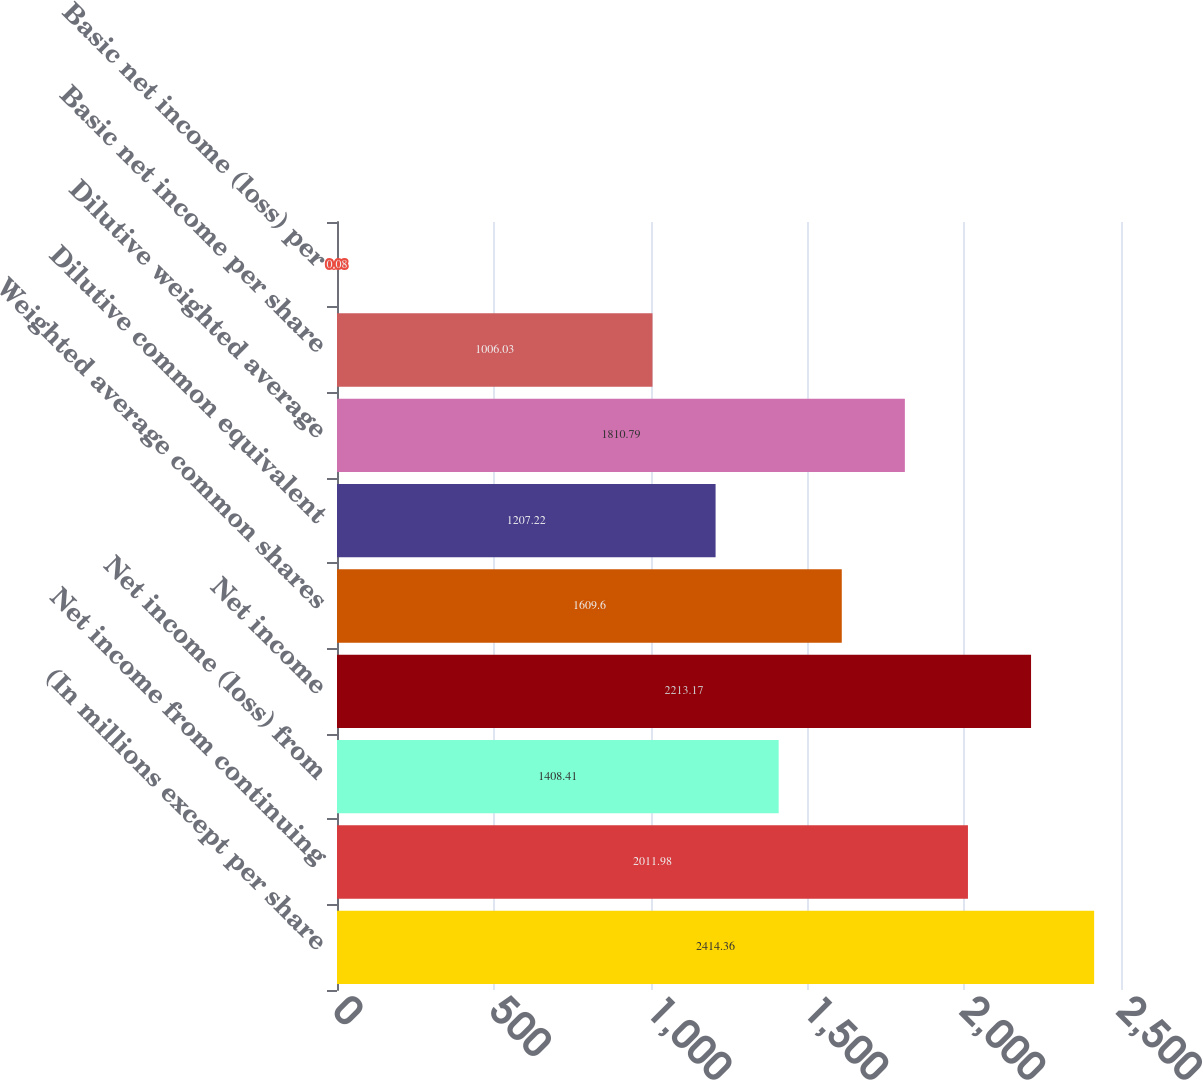<chart> <loc_0><loc_0><loc_500><loc_500><bar_chart><fcel>(In millions except per share<fcel>Net income from continuing<fcel>Net income (loss) from<fcel>Net income<fcel>Weighted average common shares<fcel>Dilutive common equivalent<fcel>Dilutive weighted average<fcel>Basic net income per share<fcel>Basic net income (loss) per<nl><fcel>2414.36<fcel>2011.98<fcel>1408.41<fcel>2213.17<fcel>1609.6<fcel>1207.22<fcel>1810.79<fcel>1006.03<fcel>0.08<nl></chart> 